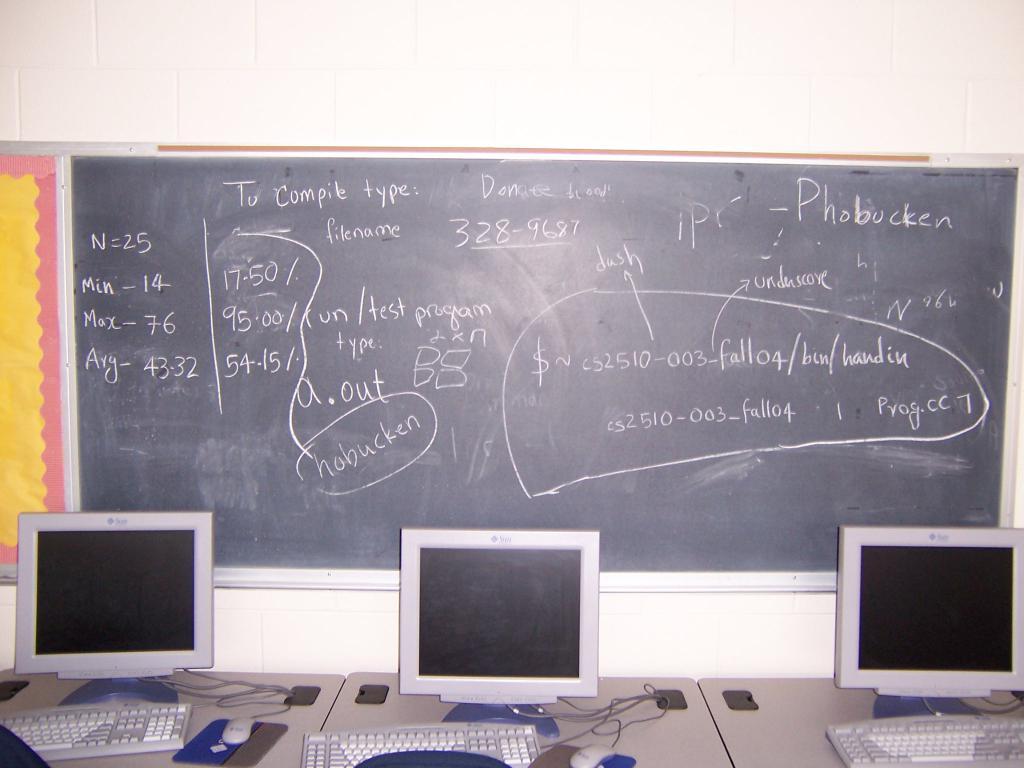What does n equal to?
Give a very brief answer. 25. What word is in the top right corner of the board?
Your answer should be compact. Phobucken. 